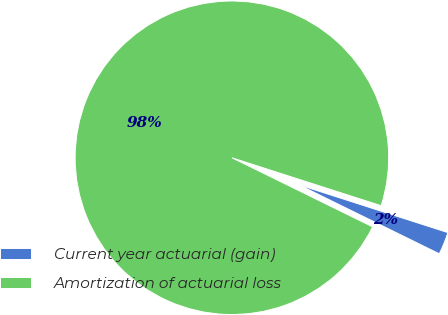<chart> <loc_0><loc_0><loc_500><loc_500><pie_chart><fcel>Current year actuarial (gain)<fcel>Amortization of actuarial loss<nl><fcel>2.32%<fcel>97.68%<nl></chart> 